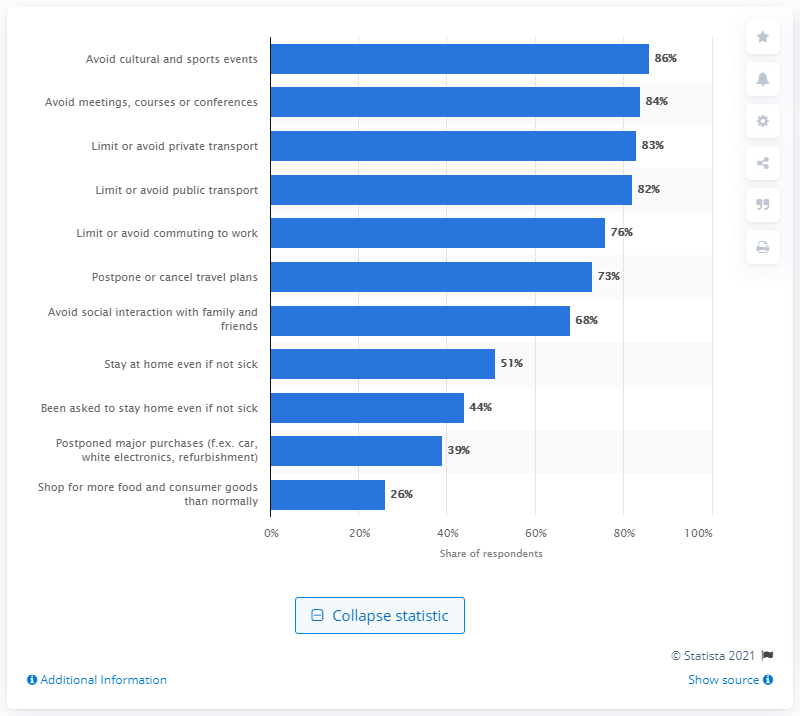Draw attention to some important aspects in this diagram. According to a survey conducted in Norway, 86% of the respondents reported that they were avoiding cultural and sports events due to the pandemic. 